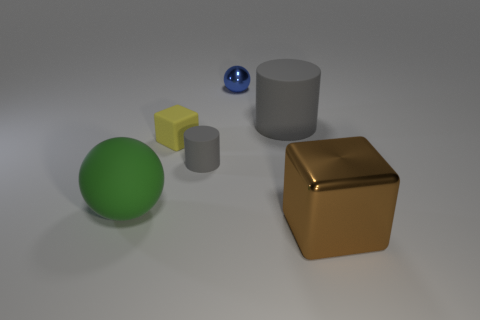How many large things have the same color as the tiny cylinder?
Offer a terse response. 1. Are there more small yellow matte blocks behind the small block than large gray cylinders?
Make the answer very short. No. There is a big rubber thing on the left side of the cube on the left side of the blue metal ball; how many yellow rubber blocks are behind it?
Provide a short and direct response. 1. Is the shape of the metallic object right of the small metal object the same as  the blue metallic object?
Give a very brief answer. No. There is a small object that is in front of the yellow matte thing; what is its material?
Your answer should be compact. Rubber. The small object that is right of the yellow matte cube and on the left side of the shiny sphere has what shape?
Keep it short and to the point. Cylinder. What is the material of the green sphere?
Your answer should be compact. Rubber. How many balls are either large gray objects or tiny yellow objects?
Give a very brief answer. 0. Is the large cylinder made of the same material as the yellow thing?
Provide a short and direct response. Yes. What is the size of the other thing that is the same shape as the small blue object?
Provide a succinct answer. Large. 